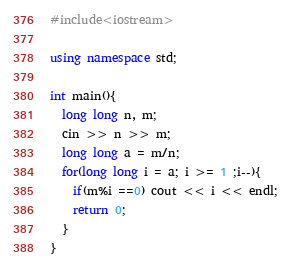<code> <loc_0><loc_0><loc_500><loc_500><_C++_>#include<iostream>

using namespace std;

int main(){
  long long n, m;
  cin >> n >> m;
  long long a = m/n;
  for(long long i = a; i >= 1 ;i--){
    if(m%i ==0) cout << i << endl;
    return 0;
  }
}
</code> 